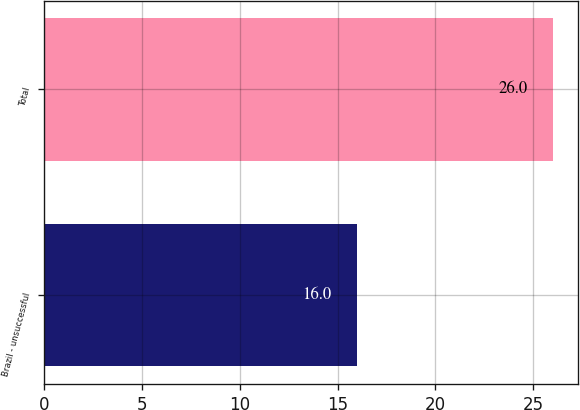<chart> <loc_0><loc_0><loc_500><loc_500><bar_chart><fcel>Brazil - unsuccessful<fcel>Total<nl><fcel>16<fcel>26<nl></chart> 